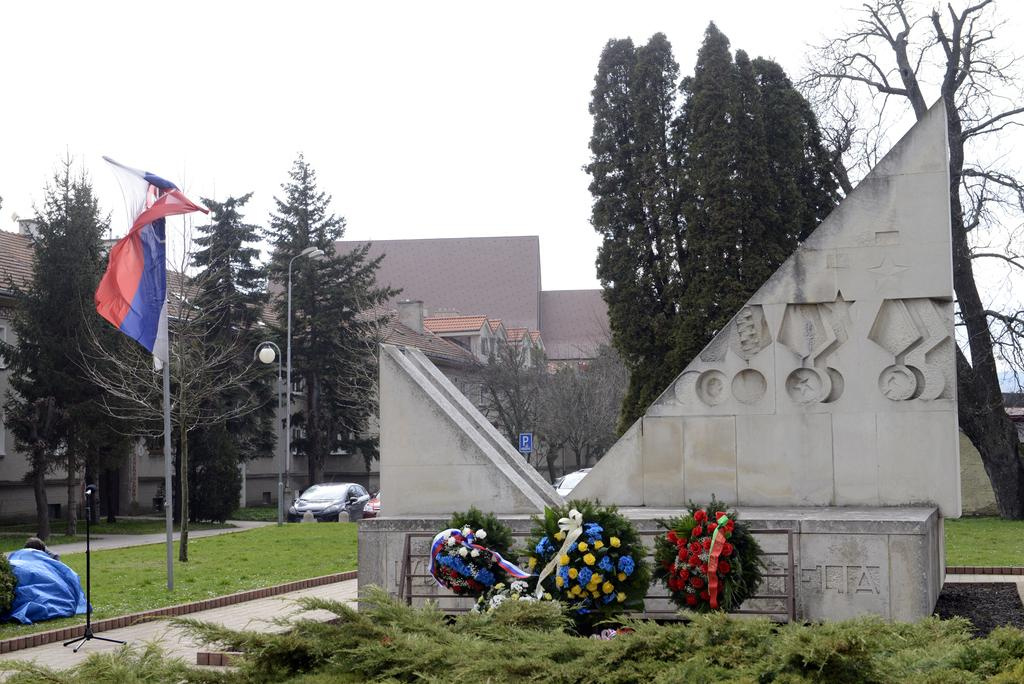What types of living organisms can be seen in the image? Plants and flowers are visible in the image. What is the main object with a pole in the image? There is a flag with a pole in the image. What can be seen in the background of the image? Grass, trees, a car, lights on poles, rooftops, and the sky are visible in the background of the image. Can you tell me how many goats are depicted on the flag in the image? There are no goats depicted on the flag or in the image; it features a flag with a design or pattern. What type of bottle is visible in the image? There is no bottle present in the image. 